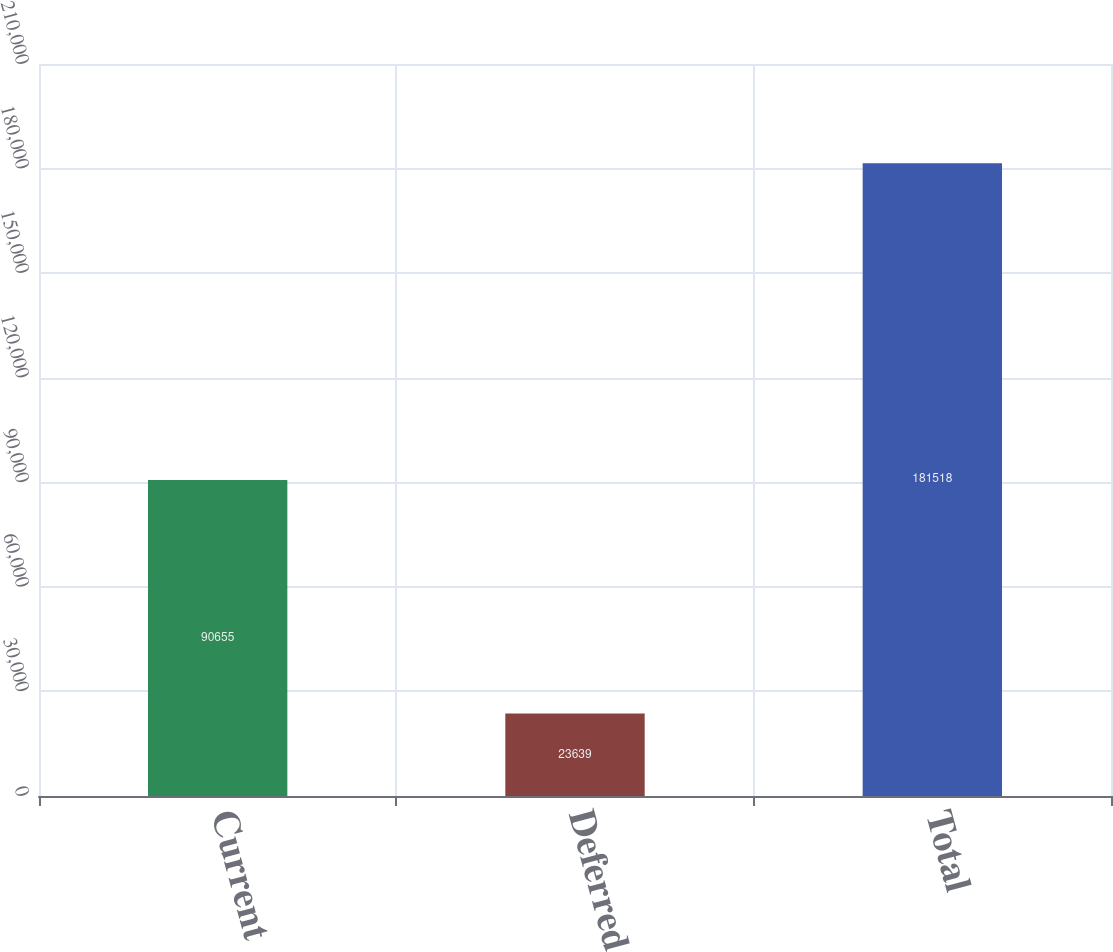<chart> <loc_0><loc_0><loc_500><loc_500><bar_chart><fcel>Current<fcel>Deferred<fcel>Total<nl><fcel>90655<fcel>23639<fcel>181518<nl></chart> 